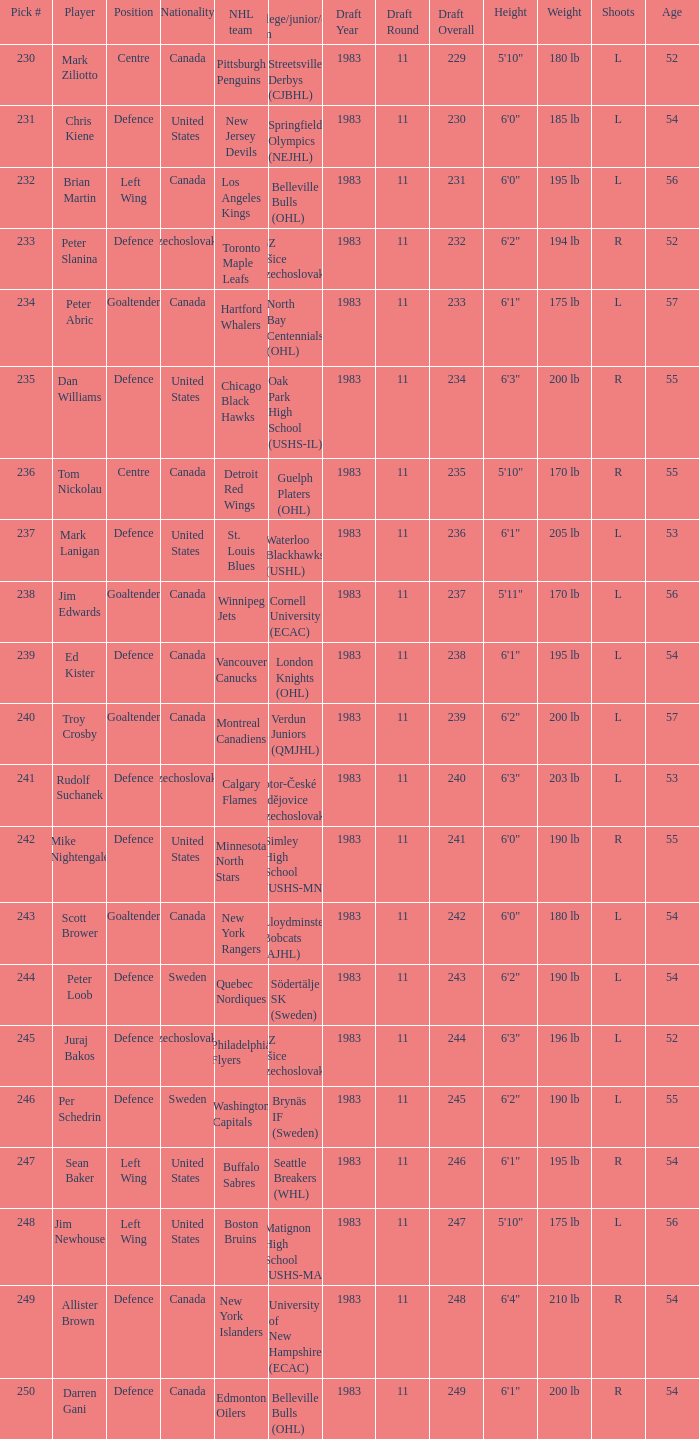List the players for team brynäs if (sweden). Per Schedrin. 